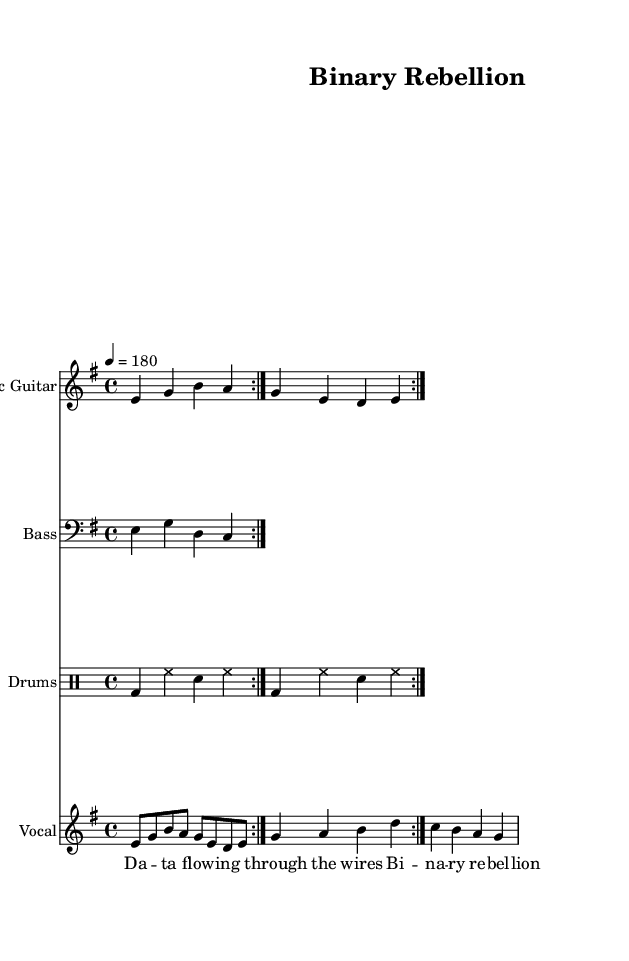What is the key signature of this music? The key signature is E minor, which contains one sharp (F#). This is determined by the information present in the global settings stated in the sheet music code under '\key e \minor'.
Answer: E minor What is the time signature of this piece? The time signature is 4/4, which indicates four beats in every measure and a quarter note gets one beat. This can be found in the global settings labeled '\time 4/4'.
Answer: 4/4 What is the tempo marking of this score? The tempo marking is quarter note equals 180 beats per minute. This indicates the speed at which the piece is intended to be played, as indicated in the global settings under '\tempo 4 = 180'.
Answer: 180 How many measures are repeated in the main guitar part? The electric guitar part has a repeated section lasting for two measures, as indicated by '\repeat volta 2' in the code, meaning to play these measures twice.
Answer: 2 What is the primary lyrical theme of the song? The primary lyrical theme involves technology and rebellion, as reflected in the lyric "Binary rebellion" which highlights the intersection of technology and societal changes, typical in fast-paced punk music.
Answer: technology and rebellion What type of drums are used in this composition? The drum part includes bass drum, hi-hat, and snare drum, which are standard components of punk rock drumming, shown in the \drummode section of the code.
Answer: Bass, Hi-hat, Snare What is the vocal range in this piece? The vocal range spans a minor seventh, as indicated by the notes being sung that range from e to b. The pitch of the vocal part demonstrates a typical punk style showcasing raw energy and expression.
Answer: Minor seventh 